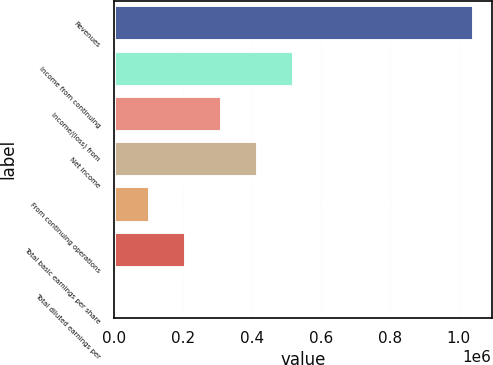Convert chart. <chart><loc_0><loc_0><loc_500><loc_500><bar_chart><fcel>Revenues<fcel>Income from continuing<fcel>Income/(loss) from<fcel>Net income<fcel>From continuing operations<fcel>Total basic earnings per share<fcel>Total diluted earnings per<nl><fcel>1.04346e+06<fcel>521730<fcel>313038<fcel>417384<fcel>104348<fcel>208693<fcel>2<nl></chart> 